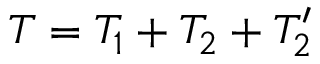<formula> <loc_0><loc_0><loc_500><loc_500>T = T _ { 1 } + T _ { 2 } + T _ { 2 } ^ { \prime }</formula> 